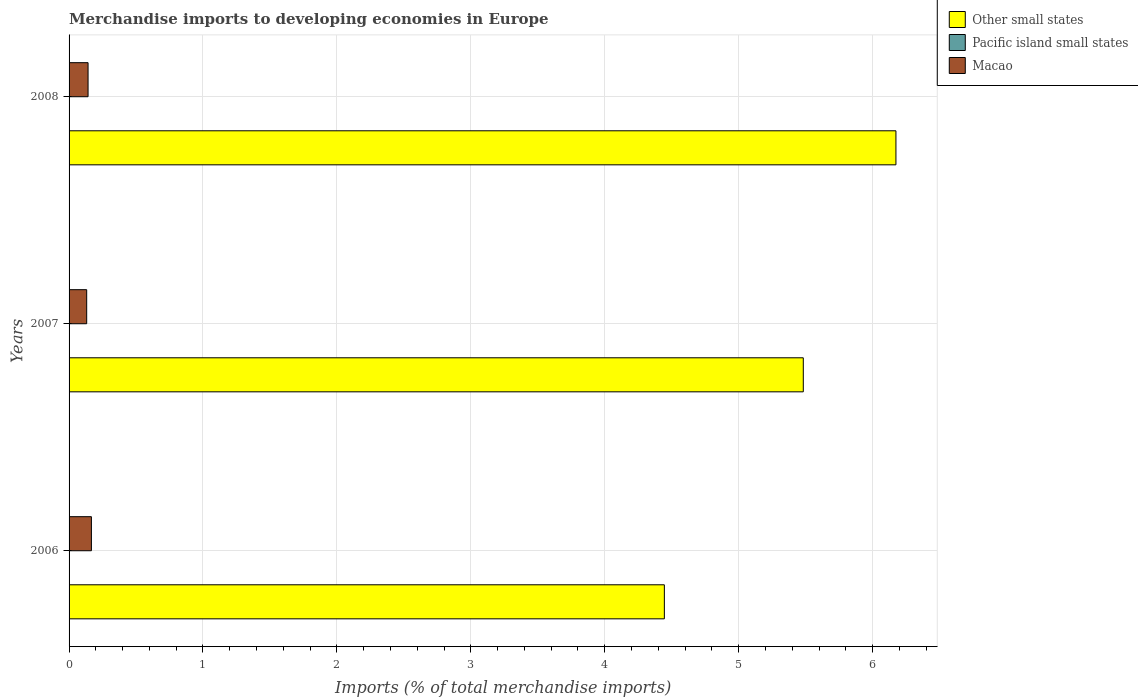How many different coloured bars are there?
Offer a very short reply. 3. Are the number of bars on each tick of the Y-axis equal?
Provide a short and direct response. Yes. How many bars are there on the 1st tick from the bottom?
Give a very brief answer. 3. In how many cases, is the number of bars for a given year not equal to the number of legend labels?
Provide a short and direct response. 0. What is the percentage total merchandise imports in Pacific island small states in 2006?
Offer a very short reply. 9.530070980074692e-5. Across all years, what is the maximum percentage total merchandise imports in Other small states?
Your response must be concise. 6.17. Across all years, what is the minimum percentage total merchandise imports in Pacific island small states?
Your answer should be compact. 9.530070980074692e-5. In which year was the percentage total merchandise imports in Other small states maximum?
Your response must be concise. 2008. What is the total percentage total merchandise imports in Pacific island small states in the graph?
Your response must be concise. 0. What is the difference between the percentage total merchandise imports in Other small states in 2007 and that in 2008?
Your answer should be compact. -0.69. What is the difference between the percentage total merchandise imports in Macao in 2008 and the percentage total merchandise imports in Other small states in 2007?
Your response must be concise. -5.34. What is the average percentage total merchandise imports in Pacific island small states per year?
Keep it short and to the point. 0. In the year 2008, what is the difference between the percentage total merchandise imports in Other small states and percentage total merchandise imports in Pacific island small states?
Provide a succinct answer. 6.17. What is the ratio of the percentage total merchandise imports in Pacific island small states in 2006 to that in 2007?
Offer a very short reply. 0.92. Is the percentage total merchandise imports in Pacific island small states in 2006 less than that in 2007?
Your answer should be compact. Yes. Is the difference between the percentage total merchandise imports in Other small states in 2006 and 2007 greater than the difference between the percentage total merchandise imports in Pacific island small states in 2006 and 2007?
Give a very brief answer. No. What is the difference between the highest and the second highest percentage total merchandise imports in Macao?
Offer a terse response. 0.02. What is the difference between the highest and the lowest percentage total merchandise imports in Pacific island small states?
Make the answer very short. 0. Is the sum of the percentage total merchandise imports in Other small states in 2006 and 2007 greater than the maximum percentage total merchandise imports in Macao across all years?
Your answer should be compact. Yes. What does the 2nd bar from the top in 2006 represents?
Your answer should be very brief. Pacific island small states. What does the 3rd bar from the bottom in 2008 represents?
Your response must be concise. Macao. How many bars are there?
Offer a very short reply. 9. How many years are there in the graph?
Offer a very short reply. 3. Are the values on the major ticks of X-axis written in scientific E-notation?
Your response must be concise. No. Does the graph contain any zero values?
Your answer should be compact. No. Where does the legend appear in the graph?
Offer a terse response. Top right. What is the title of the graph?
Give a very brief answer. Merchandise imports to developing economies in Europe. Does "Low & middle income" appear as one of the legend labels in the graph?
Provide a short and direct response. No. What is the label or title of the X-axis?
Your answer should be compact. Imports (% of total merchandise imports). What is the Imports (% of total merchandise imports) in Other small states in 2006?
Ensure brevity in your answer.  4.45. What is the Imports (% of total merchandise imports) in Pacific island small states in 2006?
Ensure brevity in your answer.  9.530070980074692e-5. What is the Imports (% of total merchandise imports) in Macao in 2006?
Your response must be concise. 0.17. What is the Imports (% of total merchandise imports) of Other small states in 2007?
Keep it short and to the point. 5.48. What is the Imports (% of total merchandise imports) in Pacific island small states in 2007?
Your answer should be very brief. 0. What is the Imports (% of total merchandise imports) of Macao in 2007?
Offer a terse response. 0.13. What is the Imports (% of total merchandise imports) in Other small states in 2008?
Ensure brevity in your answer.  6.17. What is the Imports (% of total merchandise imports) in Pacific island small states in 2008?
Provide a short and direct response. 0. What is the Imports (% of total merchandise imports) of Macao in 2008?
Make the answer very short. 0.14. Across all years, what is the maximum Imports (% of total merchandise imports) of Other small states?
Give a very brief answer. 6.17. Across all years, what is the maximum Imports (% of total merchandise imports) in Pacific island small states?
Offer a terse response. 0. Across all years, what is the maximum Imports (% of total merchandise imports) in Macao?
Your answer should be compact. 0.17. Across all years, what is the minimum Imports (% of total merchandise imports) in Other small states?
Offer a very short reply. 4.45. Across all years, what is the minimum Imports (% of total merchandise imports) of Pacific island small states?
Keep it short and to the point. 9.530070980074692e-5. Across all years, what is the minimum Imports (% of total merchandise imports) of Macao?
Give a very brief answer. 0.13. What is the total Imports (% of total merchandise imports) in Other small states in the graph?
Offer a very short reply. 16.1. What is the total Imports (% of total merchandise imports) of Pacific island small states in the graph?
Keep it short and to the point. 0. What is the total Imports (% of total merchandise imports) of Macao in the graph?
Keep it short and to the point. 0.44. What is the difference between the Imports (% of total merchandise imports) of Other small states in 2006 and that in 2007?
Give a very brief answer. -1.04. What is the difference between the Imports (% of total merchandise imports) of Macao in 2006 and that in 2007?
Ensure brevity in your answer.  0.04. What is the difference between the Imports (% of total merchandise imports) of Other small states in 2006 and that in 2008?
Give a very brief answer. -1.73. What is the difference between the Imports (% of total merchandise imports) in Pacific island small states in 2006 and that in 2008?
Provide a succinct answer. -0. What is the difference between the Imports (% of total merchandise imports) of Macao in 2006 and that in 2008?
Offer a terse response. 0.02. What is the difference between the Imports (% of total merchandise imports) in Other small states in 2007 and that in 2008?
Provide a short and direct response. -0.69. What is the difference between the Imports (% of total merchandise imports) of Pacific island small states in 2007 and that in 2008?
Give a very brief answer. -0. What is the difference between the Imports (% of total merchandise imports) in Macao in 2007 and that in 2008?
Provide a succinct answer. -0.01. What is the difference between the Imports (% of total merchandise imports) in Other small states in 2006 and the Imports (% of total merchandise imports) in Pacific island small states in 2007?
Your response must be concise. 4.45. What is the difference between the Imports (% of total merchandise imports) in Other small states in 2006 and the Imports (% of total merchandise imports) in Macao in 2007?
Provide a succinct answer. 4.31. What is the difference between the Imports (% of total merchandise imports) of Pacific island small states in 2006 and the Imports (% of total merchandise imports) of Macao in 2007?
Offer a very short reply. -0.13. What is the difference between the Imports (% of total merchandise imports) in Other small states in 2006 and the Imports (% of total merchandise imports) in Pacific island small states in 2008?
Your answer should be very brief. 4.44. What is the difference between the Imports (% of total merchandise imports) in Other small states in 2006 and the Imports (% of total merchandise imports) in Macao in 2008?
Your response must be concise. 4.3. What is the difference between the Imports (% of total merchandise imports) in Pacific island small states in 2006 and the Imports (% of total merchandise imports) in Macao in 2008?
Provide a short and direct response. -0.14. What is the difference between the Imports (% of total merchandise imports) in Other small states in 2007 and the Imports (% of total merchandise imports) in Pacific island small states in 2008?
Keep it short and to the point. 5.48. What is the difference between the Imports (% of total merchandise imports) of Other small states in 2007 and the Imports (% of total merchandise imports) of Macao in 2008?
Give a very brief answer. 5.34. What is the difference between the Imports (% of total merchandise imports) of Pacific island small states in 2007 and the Imports (% of total merchandise imports) of Macao in 2008?
Offer a terse response. -0.14. What is the average Imports (% of total merchandise imports) in Other small states per year?
Ensure brevity in your answer.  5.37. What is the average Imports (% of total merchandise imports) of Pacific island small states per year?
Your answer should be very brief. 0. What is the average Imports (% of total merchandise imports) of Macao per year?
Ensure brevity in your answer.  0.15. In the year 2006, what is the difference between the Imports (% of total merchandise imports) of Other small states and Imports (% of total merchandise imports) of Pacific island small states?
Your answer should be compact. 4.45. In the year 2006, what is the difference between the Imports (% of total merchandise imports) of Other small states and Imports (% of total merchandise imports) of Macao?
Your answer should be very brief. 4.28. In the year 2006, what is the difference between the Imports (% of total merchandise imports) of Pacific island small states and Imports (% of total merchandise imports) of Macao?
Ensure brevity in your answer.  -0.17. In the year 2007, what is the difference between the Imports (% of total merchandise imports) in Other small states and Imports (% of total merchandise imports) in Pacific island small states?
Ensure brevity in your answer.  5.48. In the year 2007, what is the difference between the Imports (% of total merchandise imports) in Other small states and Imports (% of total merchandise imports) in Macao?
Keep it short and to the point. 5.35. In the year 2007, what is the difference between the Imports (% of total merchandise imports) in Pacific island small states and Imports (% of total merchandise imports) in Macao?
Keep it short and to the point. -0.13. In the year 2008, what is the difference between the Imports (% of total merchandise imports) in Other small states and Imports (% of total merchandise imports) in Pacific island small states?
Make the answer very short. 6.17. In the year 2008, what is the difference between the Imports (% of total merchandise imports) of Other small states and Imports (% of total merchandise imports) of Macao?
Provide a short and direct response. 6.03. In the year 2008, what is the difference between the Imports (% of total merchandise imports) of Pacific island small states and Imports (% of total merchandise imports) of Macao?
Ensure brevity in your answer.  -0.14. What is the ratio of the Imports (% of total merchandise imports) of Other small states in 2006 to that in 2007?
Keep it short and to the point. 0.81. What is the ratio of the Imports (% of total merchandise imports) in Pacific island small states in 2006 to that in 2007?
Offer a terse response. 0.92. What is the ratio of the Imports (% of total merchandise imports) of Macao in 2006 to that in 2007?
Provide a short and direct response. 1.27. What is the ratio of the Imports (% of total merchandise imports) of Other small states in 2006 to that in 2008?
Offer a very short reply. 0.72. What is the ratio of the Imports (% of total merchandise imports) of Pacific island small states in 2006 to that in 2008?
Keep it short and to the point. 0.03. What is the ratio of the Imports (% of total merchandise imports) in Macao in 2006 to that in 2008?
Offer a very short reply. 1.18. What is the ratio of the Imports (% of total merchandise imports) of Other small states in 2007 to that in 2008?
Give a very brief answer. 0.89. What is the ratio of the Imports (% of total merchandise imports) in Pacific island small states in 2007 to that in 2008?
Offer a very short reply. 0.04. What is the ratio of the Imports (% of total merchandise imports) in Macao in 2007 to that in 2008?
Your answer should be compact. 0.93. What is the difference between the highest and the second highest Imports (% of total merchandise imports) in Other small states?
Keep it short and to the point. 0.69. What is the difference between the highest and the second highest Imports (% of total merchandise imports) of Pacific island small states?
Keep it short and to the point. 0. What is the difference between the highest and the second highest Imports (% of total merchandise imports) in Macao?
Make the answer very short. 0.02. What is the difference between the highest and the lowest Imports (% of total merchandise imports) in Other small states?
Offer a very short reply. 1.73. What is the difference between the highest and the lowest Imports (% of total merchandise imports) of Pacific island small states?
Ensure brevity in your answer.  0. What is the difference between the highest and the lowest Imports (% of total merchandise imports) in Macao?
Provide a succinct answer. 0.04. 